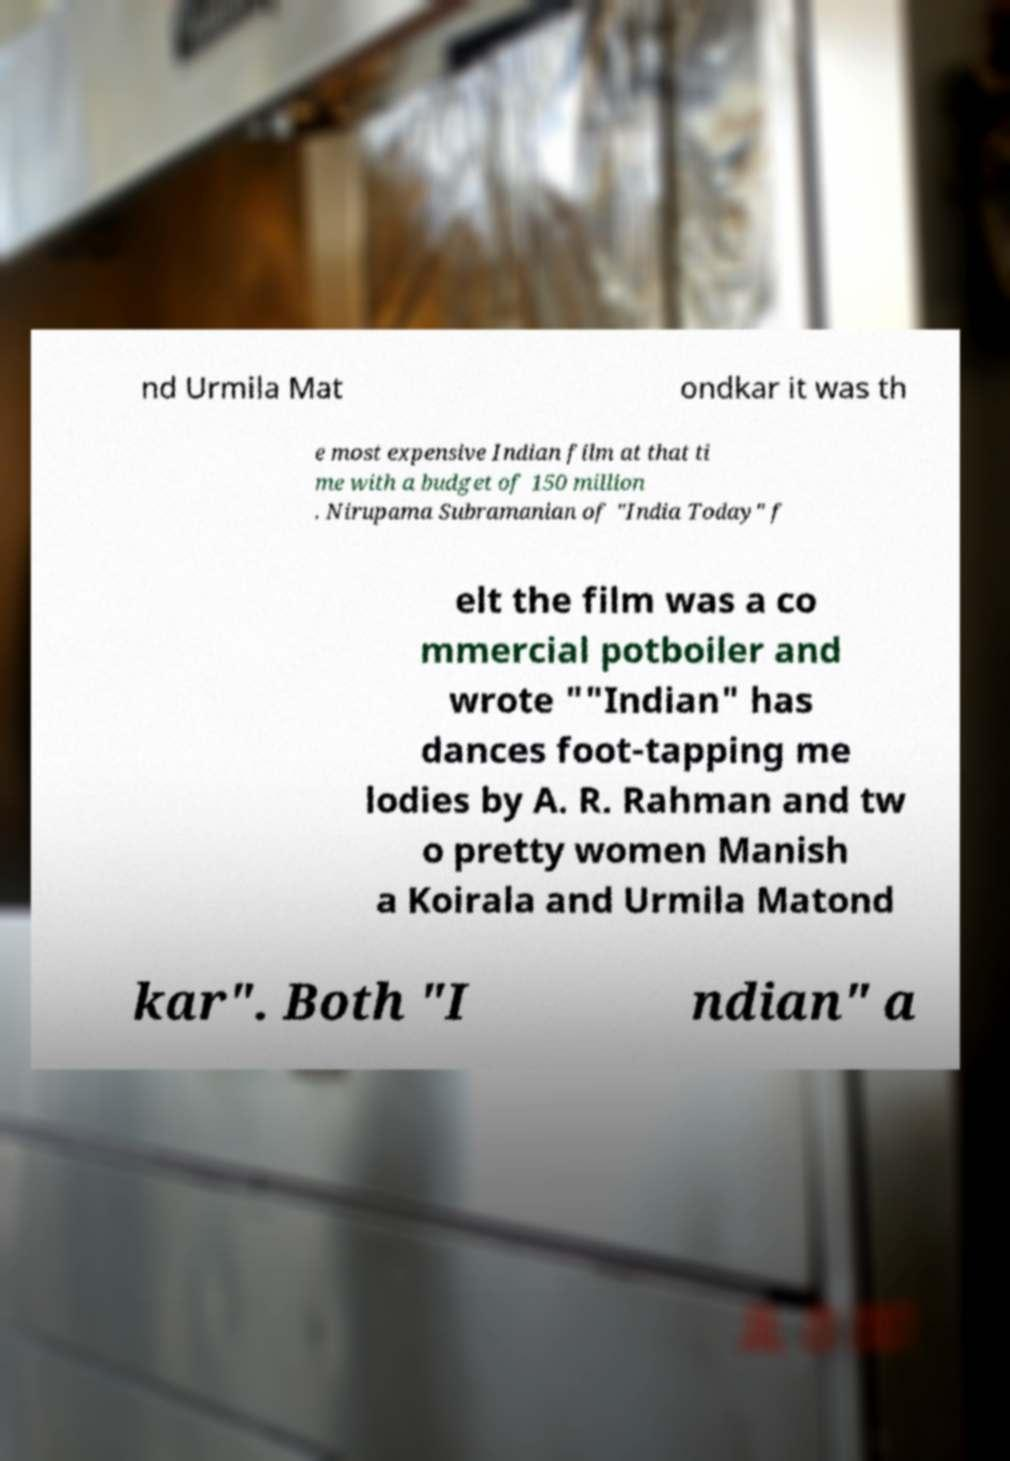Could you assist in decoding the text presented in this image and type it out clearly? nd Urmila Mat ondkar it was th e most expensive Indian film at that ti me with a budget of 150 million . Nirupama Subramanian of "India Today" f elt the film was a co mmercial potboiler and wrote ""Indian" has dances foot-tapping me lodies by A. R. Rahman and tw o pretty women Manish a Koirala and Urmila Matond kar". Both "I ndian" a 